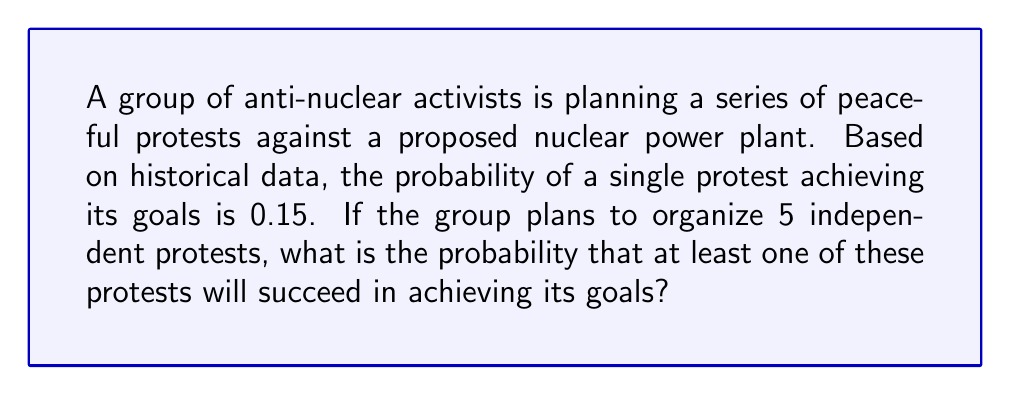Give your solution to this math problem. Let's approach this step-by-step:

1) First, we need to recognize that this is a binomial probability problem. We're looking for the probability of at least one success in 5 independent trials.

2) It's often easier to calculate the probability of at least one success by subtracting the probability of no successes from 1.

3) Let $X$ be the number of successful protests. We want to find $P(X \geq 1)$.

4) $P(X \geq 1) = 1 - P(X = 0)$

5) The probability of no successes in 5 trials is:

   $P(X = 0) = (1 - 0.15)^5 = 0.85^5$

6) Now we can calculate:

   $P(X \geq 1) = 1 - 0.85^5$

7) $0.85^5 \approx 0.4437$

8) Therefore, $P(X \geq 1) \approx 1 - 0.4437 = 0.5563$

9) Converting to a percentage: $0.5563 \times 100\% \approx 55.63\%$
Answer: $55.63\%$ 